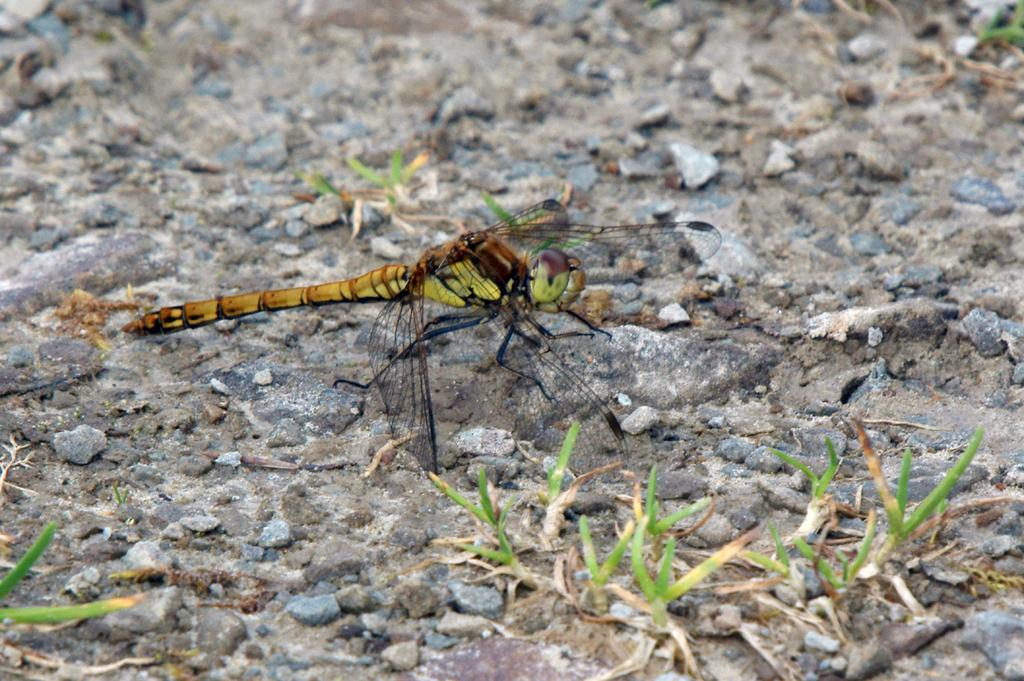What type of animal is in the picture? There is a grasshopper in the picture. What colors can be seen on the grasshopper? The grasshopper is yellow and brown in color. Where is the grasshopper located in the image? The grasshopper is sitting on the ground. What type of vegetation is visible in the image? There is small grass visible in the image. What flavor of bird can be seen in the image? There is no bird present in the image, so it is not possible to determine the flavor of any bird. 